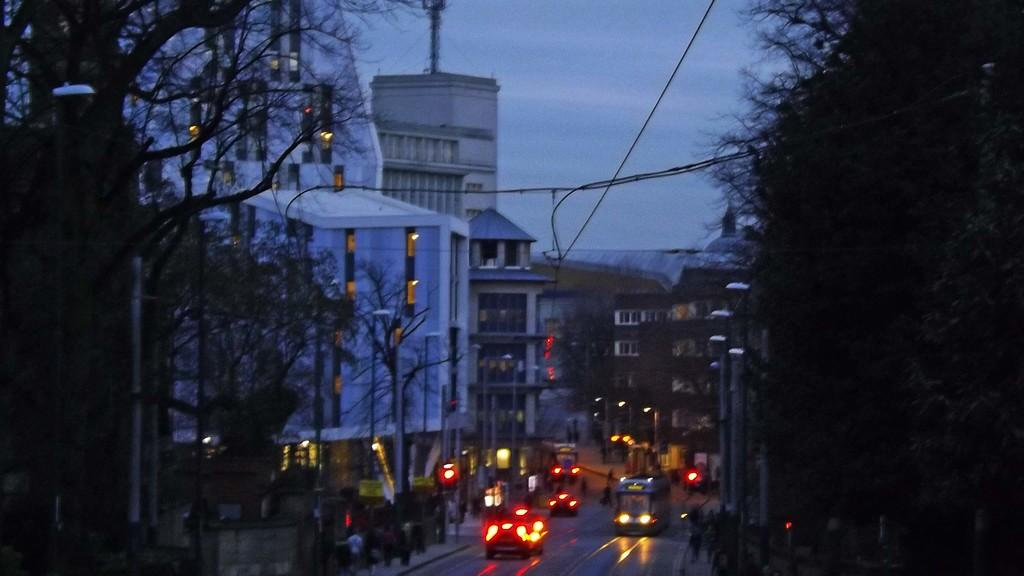What type of structures can be seen in the image? There are buildings with windows in the image. What else is present on the ground in the image? There are vehicles on the road in the image. What type of vegetation is visible in the image? There are trees in the image. What is visible above the structures and vehicles in the image? The sky is visible in the image. What arithmetic problem is being solved by the trees in the image? There is no arithmetic problem being solved by the trees in the image; they are simply trees. What type of yarn is being used to create the sky in the image? There is no yarn present in the image; the sky is a natural part of the scene. 